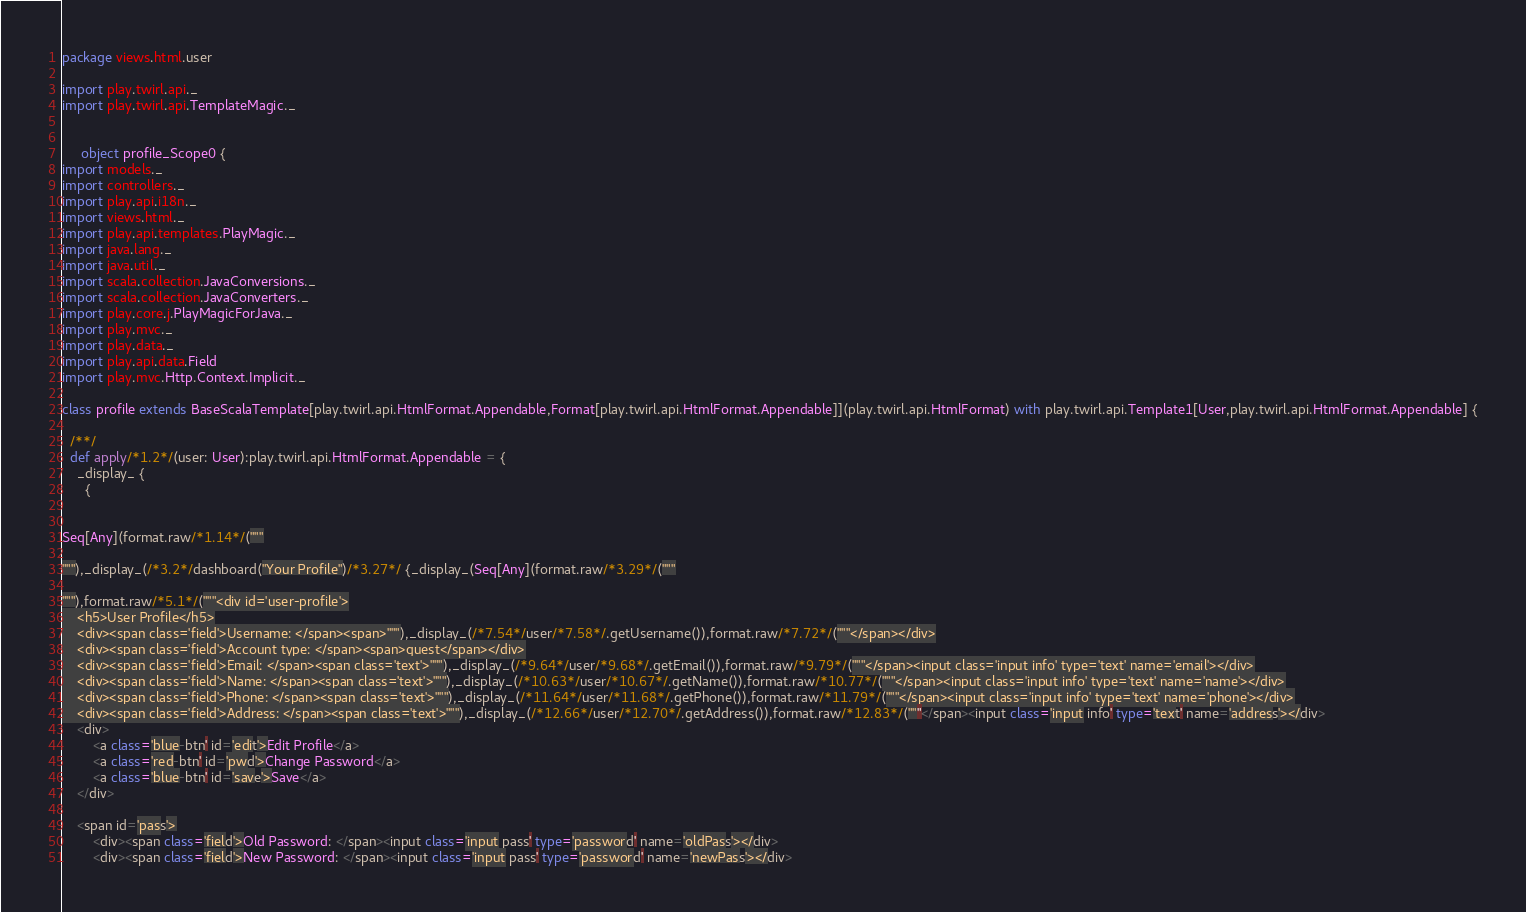Convert code to text. <code><loc_0><loc_0><loc_500><loc_500><_Scala_>
package views.html.user

import play.twirl.api._
import play.twirl.api.TemplateMagic._


     object profile_Scope0 {
import models._
import controllers._
import play.api.i18n._
import views.html._
import play.api.templates.PlayMagic._
import java.lang._
import java.util._
import scala.collection.JavaConversions._
import scala.collection.JavaConverters._
import play.core.j.PlayMagicForJava._
import play.mvc._
import play.data._
import play.api.data.Field
import play.mvc.Http.Context.Implicit._

class profile extends BaseScalaTemplate[play.twirl.api.HtmlFormat.Appendable,Format[play.twirl.api.HtmlFormat.Appendable]](play.twirl.api.HtmlFormat) with play.twirl.api.Template1[User,play.twirl.api.HtmlFormat.Appendable] {

  /**/
  def apply/*1.2*/(user: User):play.twirl.api.HtmlFormat.Appendable = {
    _display_ {
      {


Seq[Any](format.raw/*1.14*/("""

"""),_display_(/*3.2*/dashboard("Your Profile")/*3.27*/ {_display_(Seq[Any](format.raw/*3.29*/("""

"""),format.raw/*5.1*/("""<div id='user-profile'>
    <h5>User Profile</h5>
    <div><span class='field'>Username: </span><span>"""),_display_(/*7.54*/user/*7.58*/.getUsername()),format.raw/*7.72*/("""</span></div>
    <div><span class='field'>Account type: </span><span>guest</span></div>
    <div><span class='field'>Email: </span><span class='text'>"""),_display_(/*9.64*/user/*9.68*/.getEmail()),format.raw/*9.79*/("""</span><input class='input info' type='text' name='email'></div>
    <div><span class='field'>Name: </span><span class='text'>"""),_display_(/*10.63*/user/*10.67*/.getName()),format.raw/*10.77*/("""</span><input class='input info' type='text' name='name'></div>
    <div><span class='field'>Phone: </span><span class='text'>"""),_display_(/*11.64*/user/*11.68*/.getPhone()),format.raw/*11.79*/("""</span><input class='input info' type='text' name='phone'></div>
    <div><span class='field'>Address: </span><span class='text'>"""),_display_(/*12.66*/user/*12.70*/.getAddress()),format.raw/*12.83*/("""</span><input class='input info' type='text' name='address'></div>
    <div>
        <a class='blue-btn' id='edit'>Edit Profile</a>
        <a class='red-btn' id='pwd'>Change Password</a>
        <a class='blue-btn' id='save'>Save</a>
    </div>
    
    <span id='pass'>
        <div><span class='field'>Old Password: </span><input class='input pass' type='password' name='oldPass'></div>
        <div><span class='field'>New Password: </span><input class='input pass' type='password' name='newPass'></div></code> 